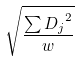Convert formula to latex. <formula><loc_0><loc_0><loc_500><loc_500>\sqrt { \frac { \sum { D _ { j } } ^ { 2 } } { w } }</formula> 